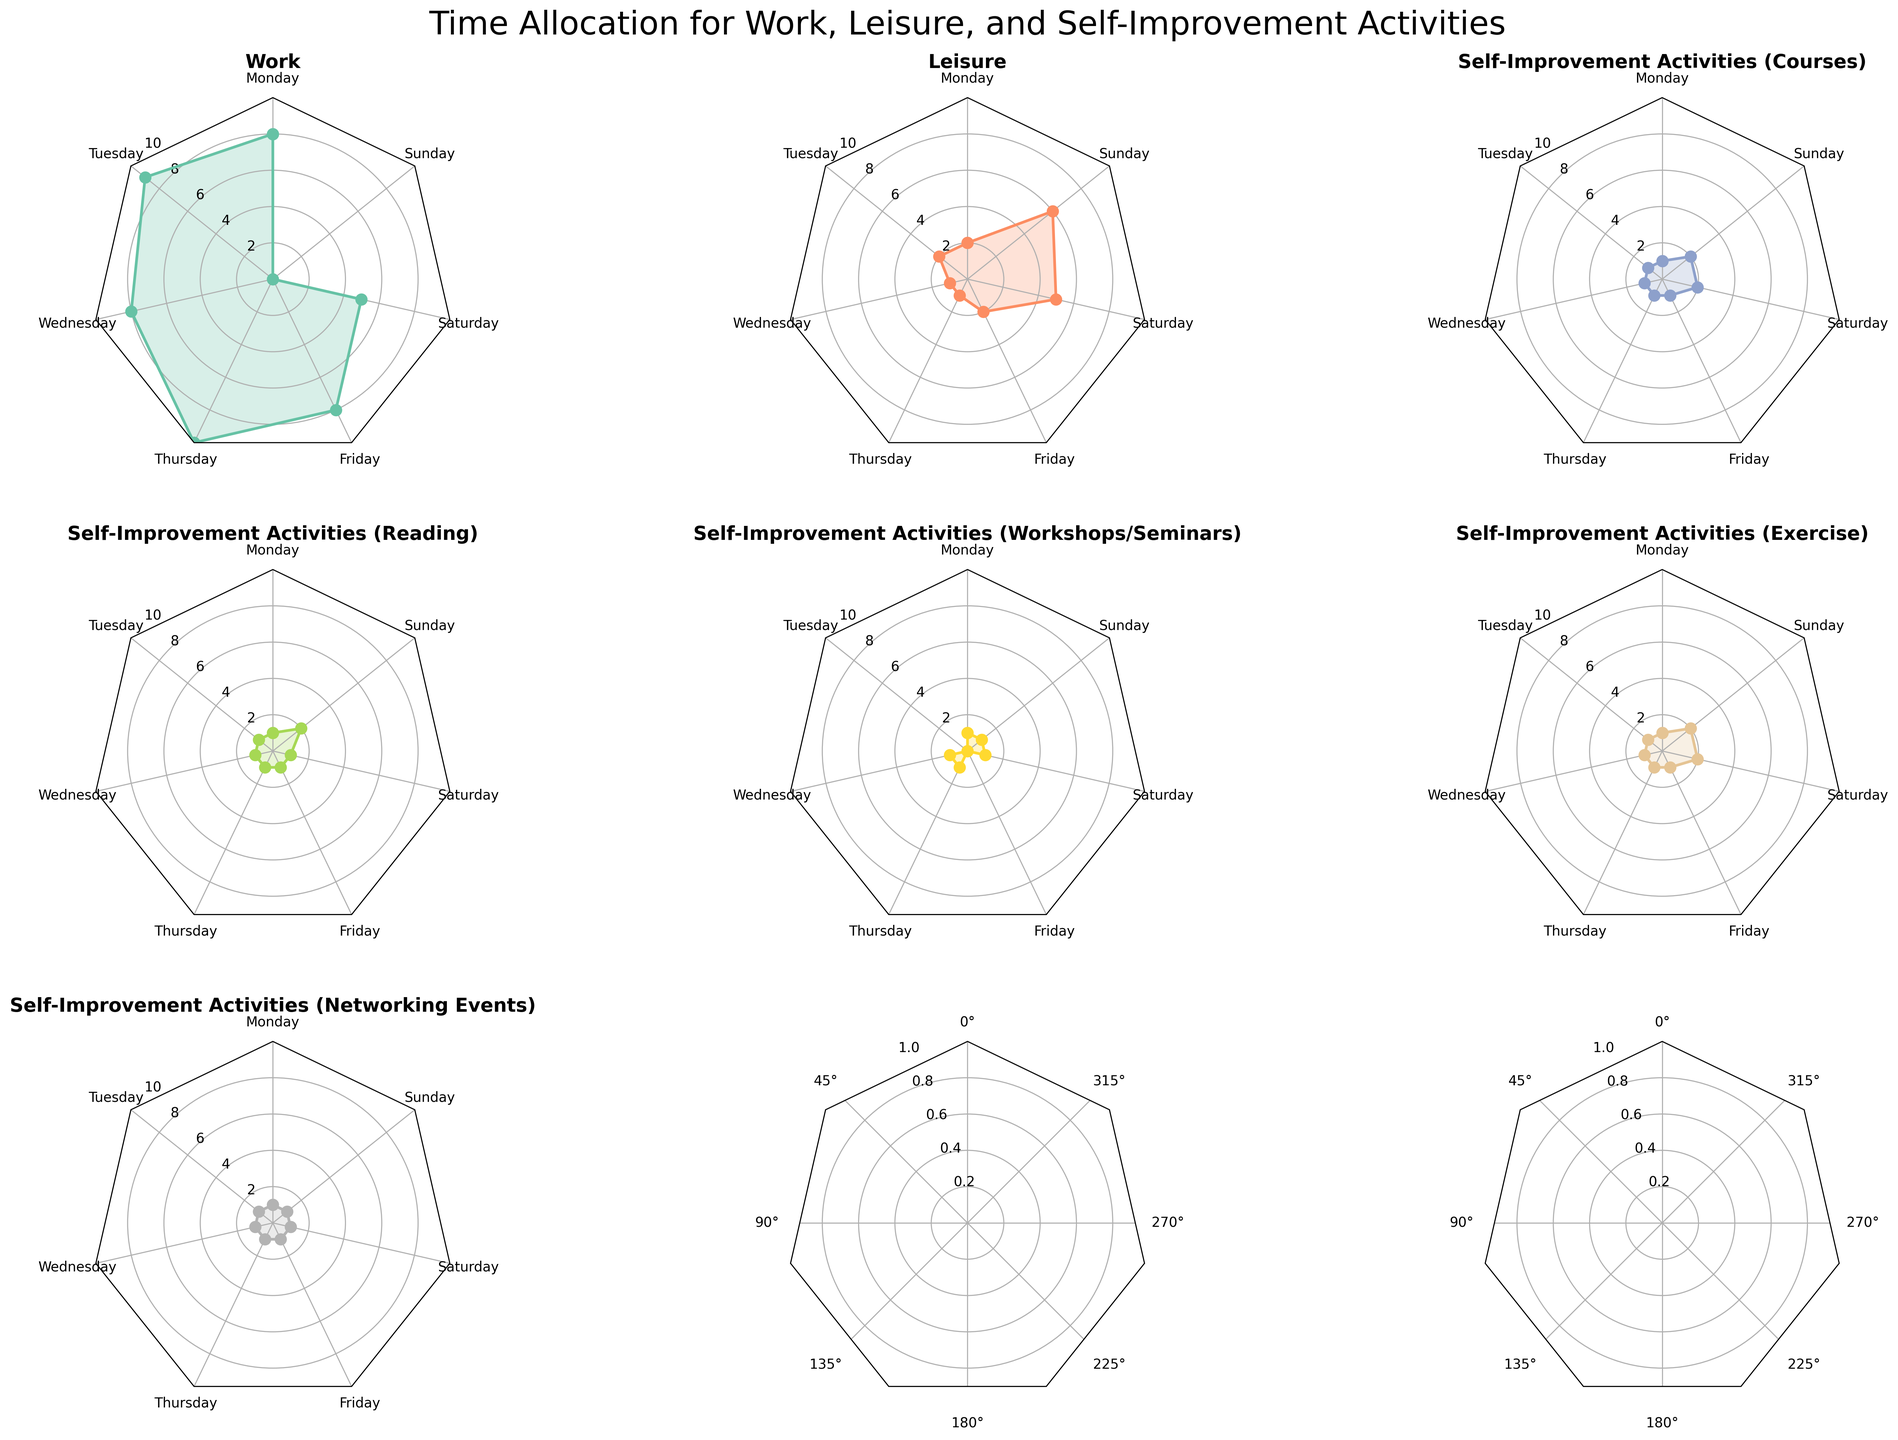Which category has the highest total time allocated on weekdays (Monday to Friday)? Sum the values for each category from Monday to Friday, then compare them to find the highest total time. For Work: 8+9+8+10+8=43 hours, Leisure: 2+2+1+1+2=8 hours, Self-Improvement Activities (Courses): 1+1+1+1+1=5 hours, Self-Improvement Activities (Reading): 1+1+1+1+1=5 hours, Self-Improvement Activities (Workshops/Seminars): 1+0+1+1+0=3 hours, Self-Improvement Activities (Exercise): 1+1+1+1+1=5 hours, Self-Improvement Activities (Networking Events): 1+1+1+1+1=5 hours. The highest is Work with 43 hours.
Answer: Work What is the total time allocated to Leisure activities on weekends (Saturday and Sunday)? Add the values for Leisure on Saturday and Sunday. For Leisure: 5+6=11 hours.
Answer: 11 hours Which day shows the highest allocation of time for Self-Improvement Activities (Reading)? Identify the day with the highest value in the Self-Improvement Activities (Reading) category. The values are: Monday=1, Tuesday=1, Wednesday=1, Thursday=1, Friday=1, Saturday=1, Sunday=2. The highest is Sunday with 2 hours.
Answer: Sunday Do Self-Improvement Activities (Courses) show consistent time allocation throughout the week? Check the values for Self-Improvement Activities (Courses) across all days. The values are: 1, 1, 1, 1, 1, 2, 2. The time allocation is not entirely consistent since Saturday and Sunday show higher values.
Answer: No Compare the time allocated to Work on Monday and Thursday. Which day has more time allocated and by how much? Work hours on Monday = 8. Work hours on Thursday = 10. Subtract Monday's value from Thursday's. Thursday has 10 - 8 = 2 hours more allocated than Monday.
Answer: Thursday by 2 hours What is the average time allocated to Exercise throughout the week? Sum the exercise hours for each day of the week and divide by 7 to find the average. Values are: 1+1+1+1+1+2+2=9. Average is 9/7 ≈ 1.29 hours.
Answer: 1.29 hours Which Self-Improvement Activity has the least amount of time allocated on Tuesday? Compare the time allocation values for each Self-Improvement Activity on Tuesday. Values are: Courses=1, Reading=1, Workshops/Seminars=0, Exercise=1, Networking Events=1. The least is Workshops/Seminars with 0 hours.
Answer: Workshops/Seminars Which day has the highest total time allocated across all categories? Sum the values for each category by day and then compare these totals to find the highest one. Monday: 14, Tuesday: 15, Wednesday: 14, Thursday: 15, Friday: 14, Saturday: 16, Sunday: 14. The highest total is on Saturday with 16 hours.
Answer: Saturday Does the time allocated to Self-Improvement Activities (Networking Events) vary throughout the week? Check the values for Self-Improvement Activities (Networking Events) across all days. The values are: 1, 1, 1, 1, 1, 1, 1. The time allocation is consistent throughout the week.
Answer: No 